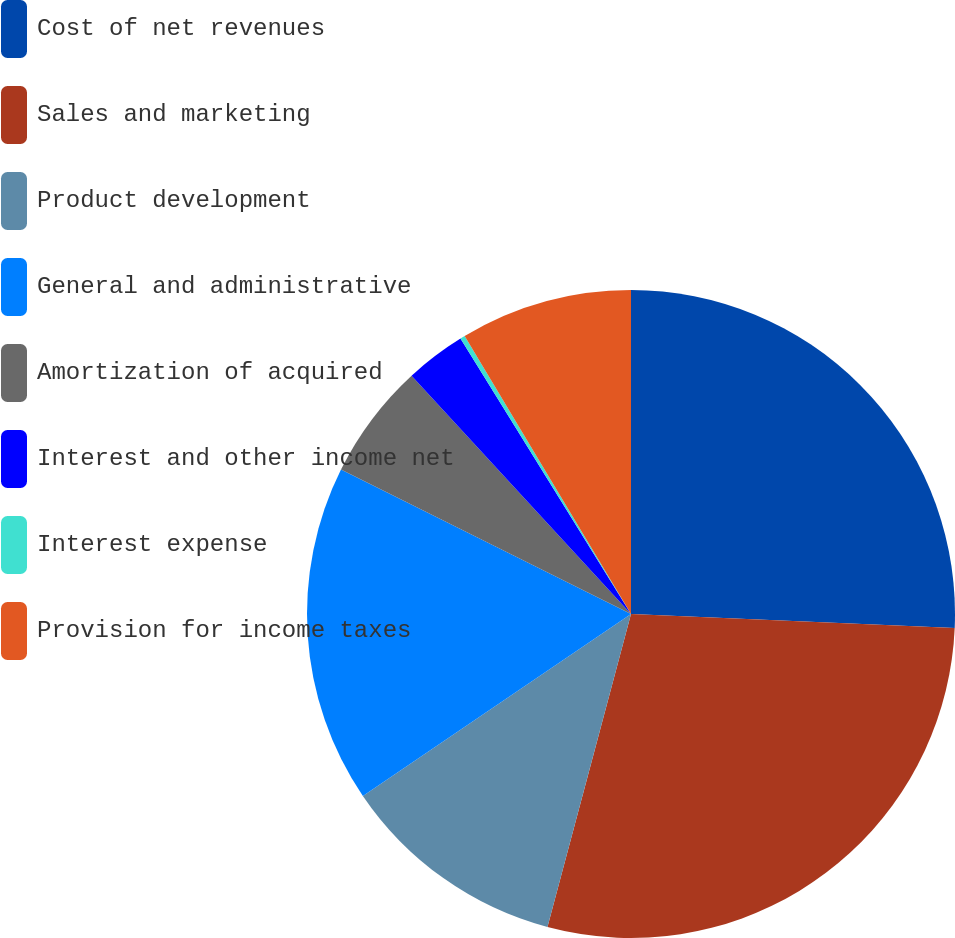Convert chart to OTSL. <chart><loc_0><loc_0><loc_500><loc_500><pie_chart><fcel>Cost of net revenues<fcel>Sales and marketing<fcel>Product development<fcel>General and administrative<fcel>Amortization of acquired<fcel>Interest and other income net<fcel>Interest expense<fcel>Provision for income taxes<nl><fcel>25.68%<fcel>28.46%<fcel>11.36%<fcel>16.84%<fcel>5.8%<fcel>3.02%<fcel>0.24%<fcel>8.58%<nl></chart> 